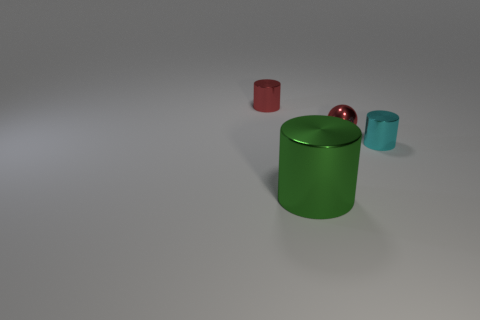Is there anything else that has the same material as the small red cylinder?
Your response must be concise. Yes. How many tiny things are yellow metallic spheres or red metal spheres?
Provide a short and direct response. 1. There is a thing that is the same color as the ball; what is its shape?
Provide a succinct answer. Cylinder. Does the small thing left of the large metal cylinder have the same material as the cyan cylinder?
Your answer should be very brief. Yes. What is the material of the red object in front of the metallic cylinder behind the red metallic sphere?
Offer a very short reply. Metal. What number of tiny gray matte objects have the same shape as the large object?
Offer a very short reply. 0. What size is the cylinder to the right of the large thing that is in front of the small red object left of the big green shiny cylinder?
Provide a succinct answer. Small. What number of red objects are big rubber cylinders or spheres?
Give a very brief answer. 1. Do the thing in front of the cyan cylinder and the small cyan object have the same shape?
Give a very brief answer. Yes. Is the number of metallic things right of the red metal cylinder greater than the number of big objects?
Your response must be concise. Yes. 